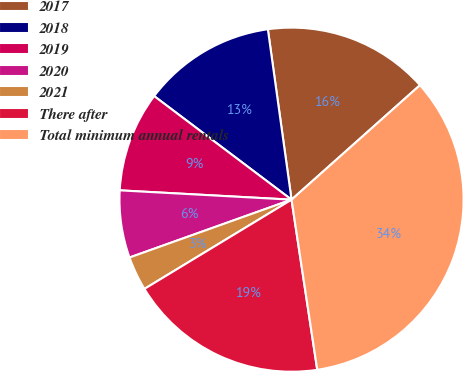<chart> <loc_0><loc_0><loc_500><loc_500><pie_chart><fcel>2017<fcel>2018<fcel>2019<fcel>2020<fcel>2021<fcel>There after<fcel>Total minimum annual rentals<nl><fcel>15.61%<fcel>12.52%<fcel>9.42%<fcel>6.32%<fcel>3.22%<fcel>18.71%<fcel>34.2%<nl></chart> 